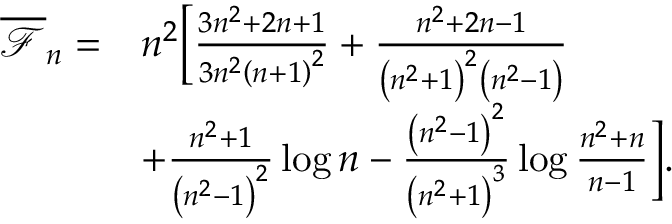Convert formula to latex. <formula><loc_0><loc_0><loc_500><loc_500>\begin{array} { r l } { \overline { { \mathcal { F } } } _ { n } = } & { n ^ { 2 } \left [ \frac { 3 n ^ { 2 } + 2 n + 1 } { 3 n ^ { 2 } \left ( n + 1 \right ) ^ { 2 } } + \frac { n ^ { 2 } + 2 n - 1 } { \left ( n ^ { 2 } + 1 \right ) ^ { 2 } \left ( n ^ { 2 } - 1 \right ) } } \\ & { + \frac { n ^ { 2 } + 1 } { \left ( n ^ { 2 } - 1 \right ) ^ { 2 } } \log n - \frac { \left ( n ^ { 2 } - 1 \right ) ^ { 2 } } { \left ( n ^ { 2 } + 1 \right ) ^ { 3 } } \log \frac { n ^ { 2 } + n } { n - 1 } \right ] . } \end{array}</formula> 